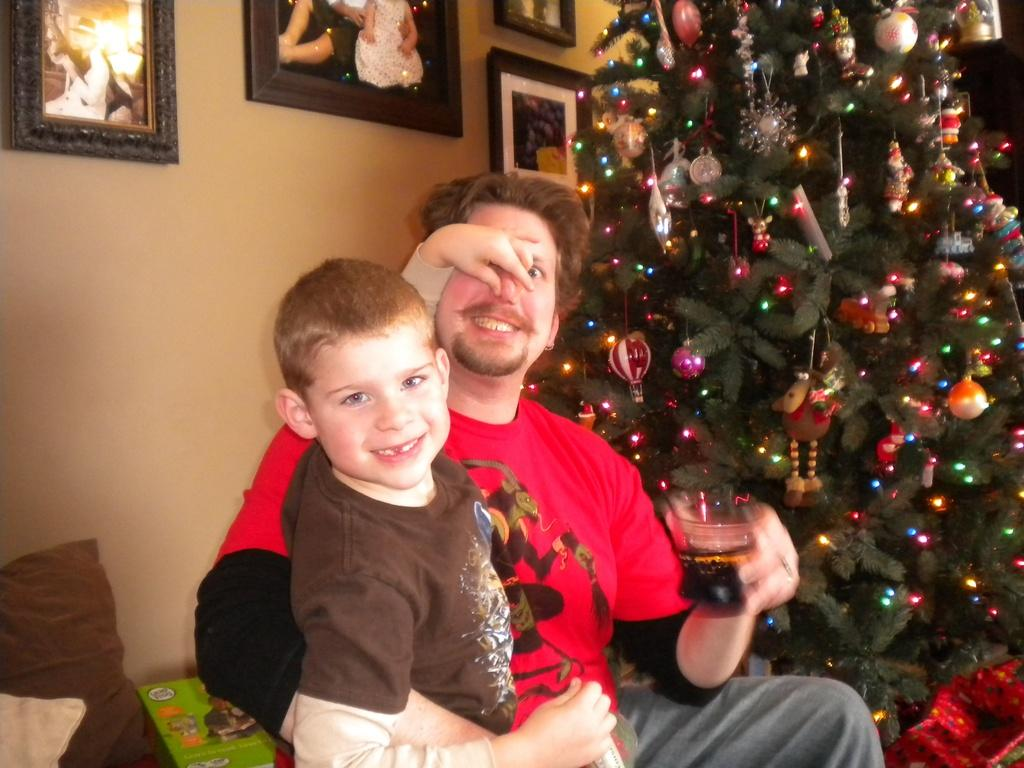Who or what is present in the image? There are people in the image. What can be seen hanging on the walls in the image? There are photo frames in the image. What is the main decoration in the image? There is a Christmas tree decorated with lights in the image. What other objects can be seen in the image besides the people, photo frames, and Christmas tree? There are other objects present in the image. What type of grip does the plough have in the image? There is no plough present in the image, so it is not possible to determine the type of grip it might have. 